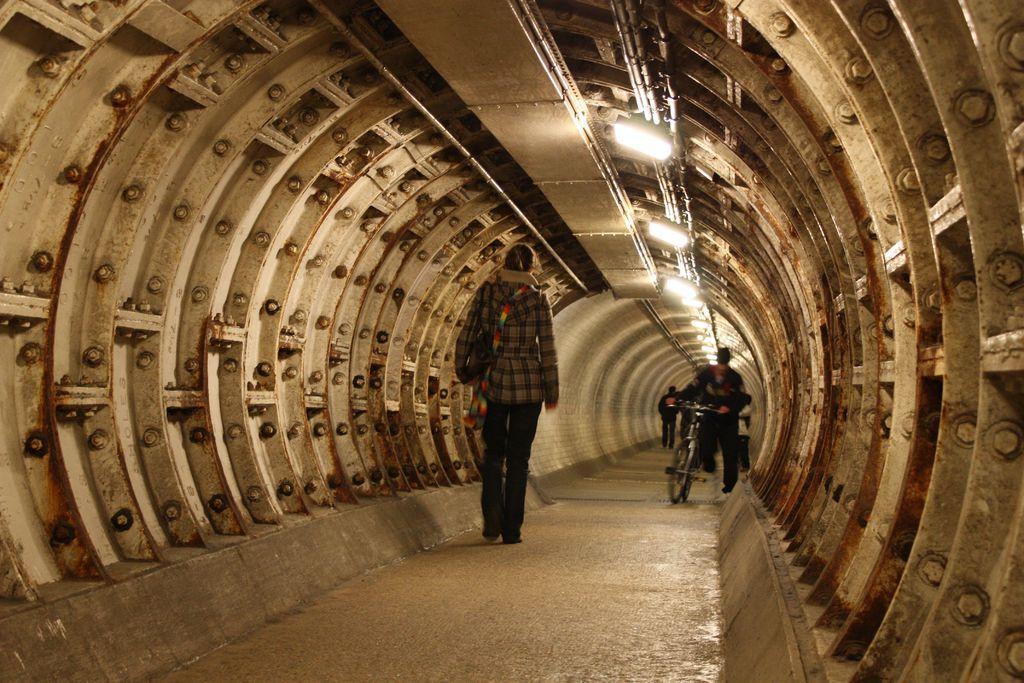Can you describe this image briefly? This image is taken inside a tunnel. There are people walking. 